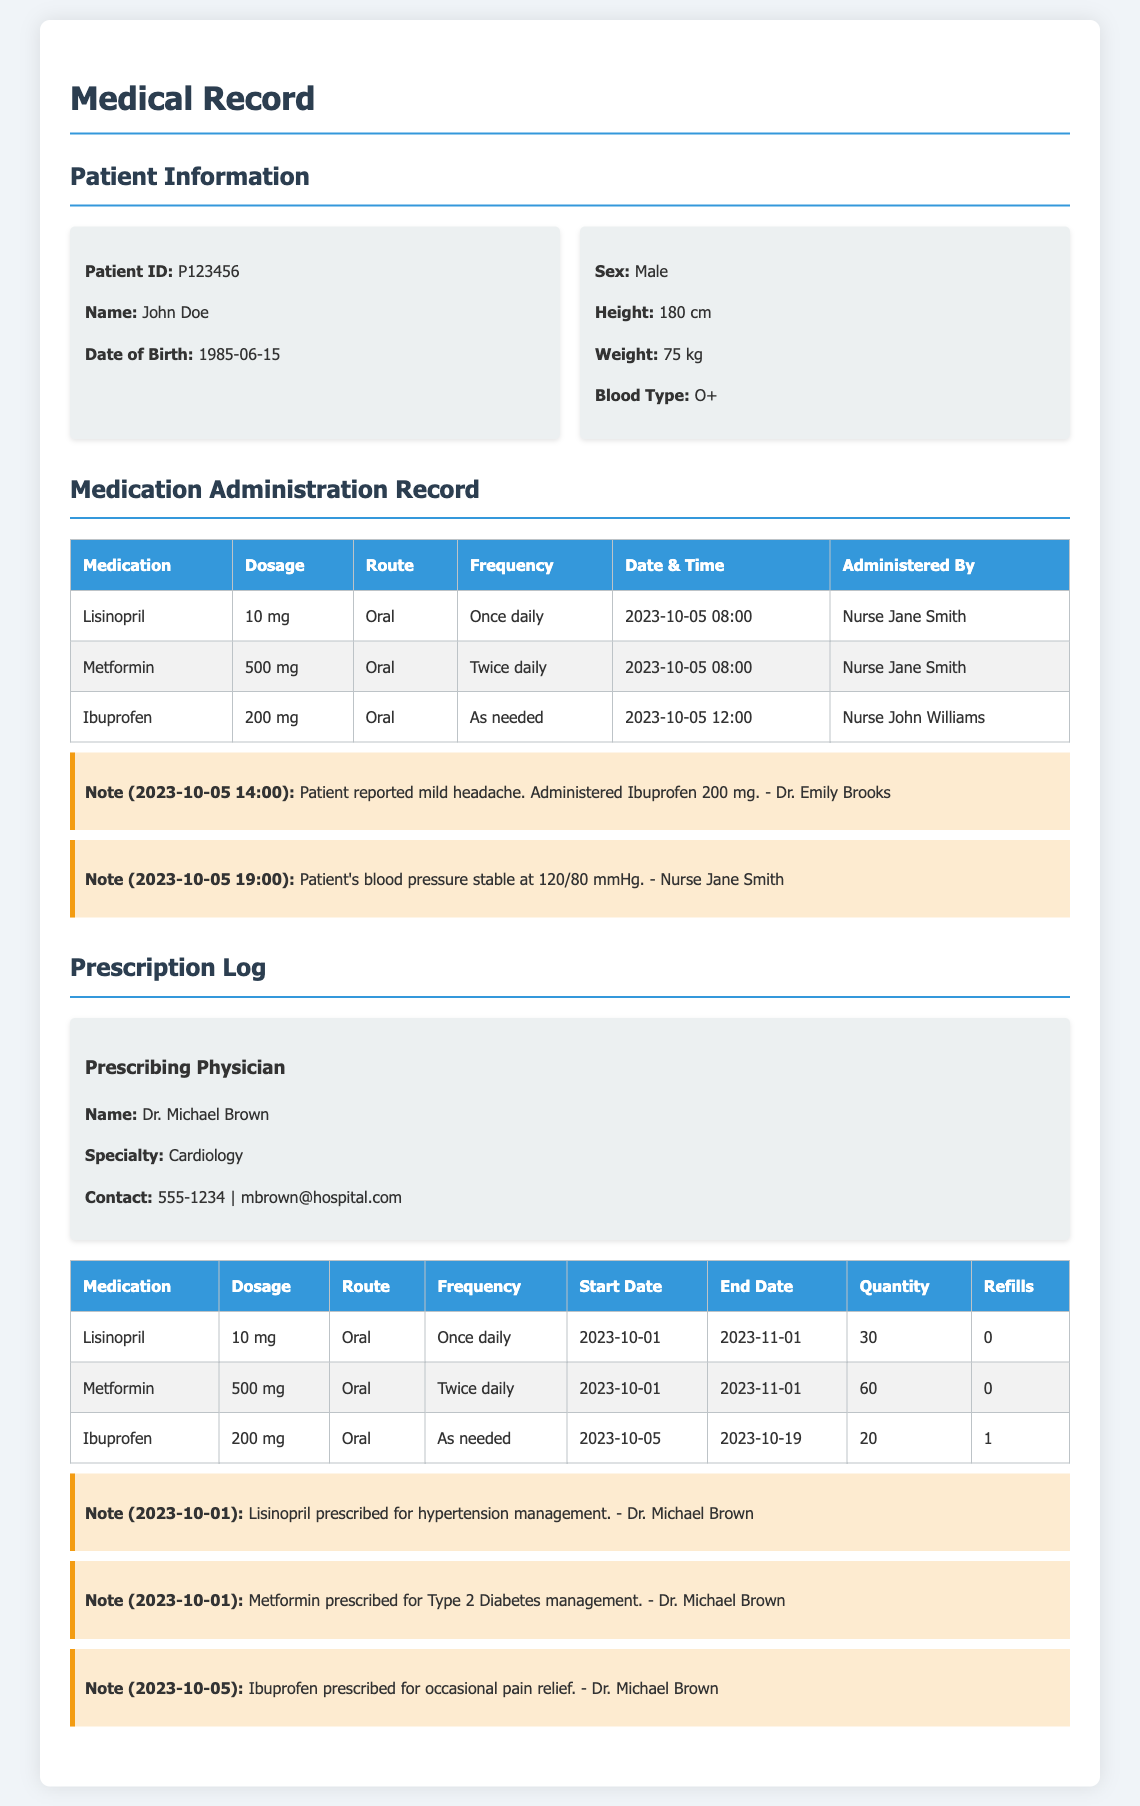what is the patient's name? The patient's name is provided in the patient information section as John Doe.
Answer: John Doe when was the last dose of Metformin administered? The last recorded administration date for Metformin is found in the Medication Administration Record as 2023-10-05.
Answer: 2023-10-05 who administered the Ibuprofen? The Medication Administration Record indicates that Ibuprofen was administered by Nurse John Williams.
Answer: Nurse John Williams how many refills were prescribed for Ibuprofen? The Prescription Log specifies that 1 refill was prescribed for Ibuprofen.
Answer: 1 what is the start date for Lisinopril? In the Prescription Log, the start date for Lisinopril is noted as 2023-10-01.
Answer: 2023-10-01 who is responsible for prescribing medications to the patient? The document lists Dr. Michael Brown as the prescribing physician in the Prescription Log.
Answer: Dr. Michael Brown which medication was prescribed for Type 2 Diabetes management? The note in the Prescription Log mentions that Metformin was prescribed for Type 2 Diabetes management.
Answer: Metformin what was noted about the patient's blood pressure? The note in the Medication Administration Record indicates the patient's blood pressure was stable at 120/80 mmHg.
Answer: 120/80 mmHg 